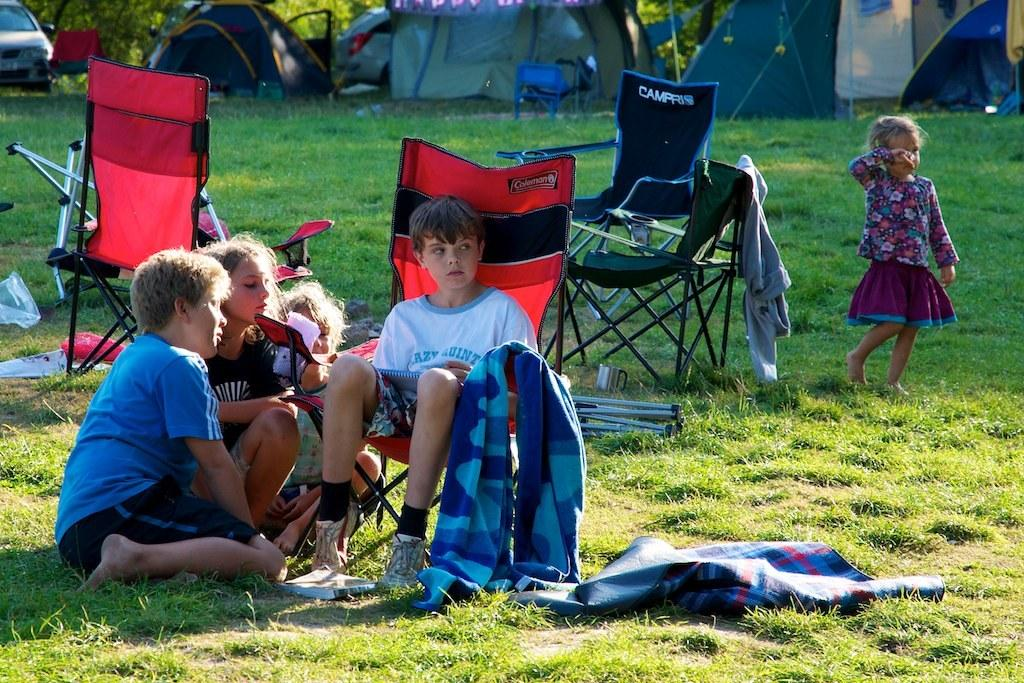How many children are sitting on the left side of the image? There are three children sitting on the left side of the image. What is the position of the boy in the image? A boy is sitting in a chair in the middle of the image. What is the girl doing in the image? A girl is walking behind the children. What type of temporary shelters can be seen in the image? There are tents in the image. What type of transportation is visible in the image? There are vehicles in the image. What type of tool is the carpenter using in the image? There is no carpenter present in the image, so no such tool can be observed. Can you tell me how many rabbits are hopping around in the image? There are no rabbits present in the image. 